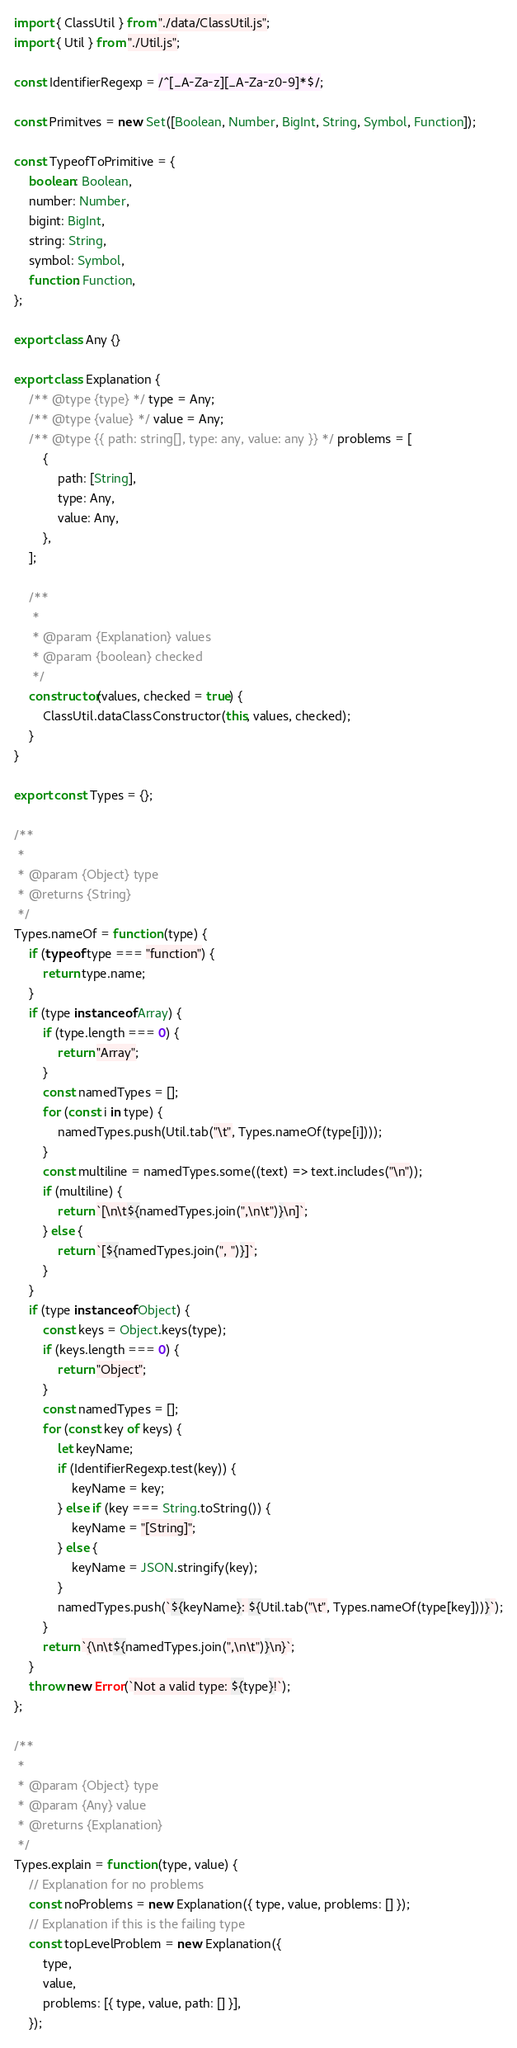Convert code to text. <code><loc_0><loc_0><loc_500><loc_500><_JavaScript_>import { ClassUtil } from "./data/ClassUtil.js";
import { Util } from "./Util.js";

const IdentifierRegexp = /^[_A-Za-z][_A-Za-z0-9]*$/;

const Primitves = new Set([Boolean, Number, BigInt, String, Symbol, Function]);

const TypeofToPrimitive = {
	boolean: Boolean,
	number: Number,
	bigint: BigInt,
	string: String,
	symbol: Symbol,
	function: Function,
};

export class Any {}

export class Explanation {
	/** @type {type} */ type = Any;
	/** @type {value} */ value = Any;
	/** @type {{ path: string[], type: any, value: any }} */ problems = [
		{
			path: [String],
			type: Any,
			value: Any,
		},
	];

	/**
	 *
	 * @param {Explanation} values
	 * @param {boolean} checked
	 */
	constructor(values, checked = true) {
		ClassUtil.dataClassConstructor(this, values, checked);
	}
}

export const Types = {};

/**
 *
 * @param {Object} type
 * @returns {String}
 */
Types.nameOf = function (type) {
	if (typeof type === "function") {
		return type.name;
	}
	if (type instanceof Array) {
		if (type.length === 0) {
			return "Array";
		}
		const namedTypes = [];
		for (const i in type) {
			namedTypes.push(Util.tab("\t", Types.nameOf(type[i])));
		}
		const multiline = namedTypes.some((text) => text.includes("\n"));
		if (multiline) {
			return `[\n\t${namedTypes.join(",\n\t")}\n]`;
		} else {
			return `[${namedTypes.join(", ")}]`;
		}
	}
	if (type instanceof Object) {
		const keys = Object.keys(type);
		if (keys.length === 0) {
			return "Object";
		}
		const namedTypes = [];
		for (const key of keys) {
			let keyName;
			if (IdentifierRegexp.test(key)) {
				keyName = key;
			} else if (key === String.toString()) {
				keyName = "[String]";
			} else {
				keyName = JSON.stringify(key);
			}
			namedTypes.push(`${keyName}: ${Util.tab("\t", Types.nameOf(type[key]))}`);
		}
		return `{\n\t${namedTypes.join(",\n\t")}\n}`;
	}
	throw new Error(`Not a valid type: ${type}!`);
};

/**
 *
 * @param {Object} type
 * @param {Any} value
 * @returns {Explanation}
 */
Types.explain = function (type, value) {
	// Explanation for no problems
	const noProblems = new Explanation({ type, value, problems: [] });
	// Explanation if this is the failing type
	const topLevelProblem = new Explanation({
		type,
		value,
		problems: [{ type, value, path: [] }],
	});</code> 